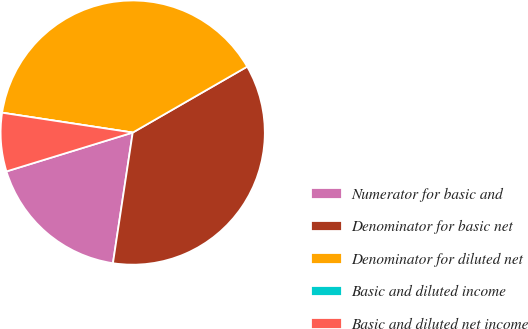Convert chart. <chart><loc_0><loc_0><loc_500><loc_500><pie_chart><fcel>Numerator for basic and<fcel>Denominator for basic net<fcel>Denominator for diluted net<fcel>Basic and diluted income<fcel>Basic and diluted net income<nl><fcel>17.86%<fcel>35.71%<fcel>39.28%<fcel>0.0%<fcel>7.15%<nl></chart> 